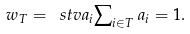Convert formula to latex. <formula><loc_0><loc_0><loc_500><loc_500>w _ { T } = \ s t v { a _ { i } } { \sum \nolimits _ { i \in T } a _ { i } = 1 } .</formula> 